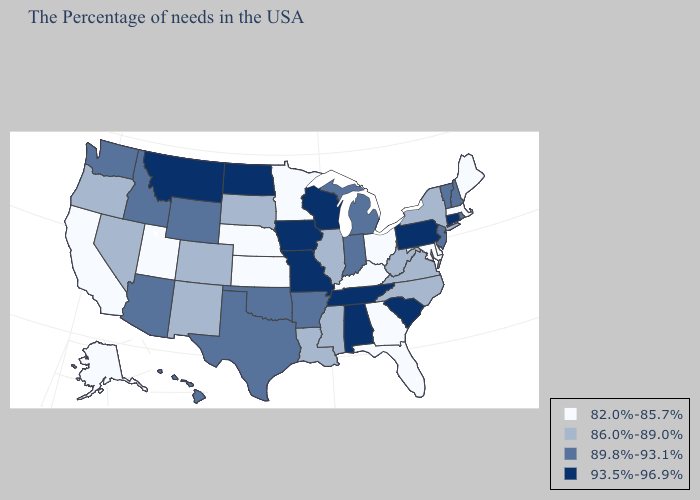What is the value of Kansas?
Quick response, please. 82.0%-85.7%. Which states hav the highest value in the Northeast?
Concise answer only. Connecticut, Pennsylvania. Name the states that have a value in the range 86.0%-89.0%?
Quick response, please. New York, Virginia, North Carolina, West Virginia, Illinois, Mississippi, Louisiana, South Dakota, Colorado, New Mexico, Nevada, Oregon. Does Louisiana have a higher value than Utah?
Give a very brief answer. Yes. What is the lowest value in states that border Florida?
Be succinct. 82.0%-85.7%. Does Colorado have the same value as Oklahoma?
Concise answer only. No. What is the lowest value in states that border Connecticut?
Short answer required. 82.0%-85.7%. Does Massachusetts have the lowest value in the Northeast?
Be succinct. Yes. What is the lowest value in states that border Alabama?
Short answer required. 82.0%-85.7%. Name the states that have a value in the range 89.8%-93.1%?
Concise answer only. Rhode Island, New Hampshire, Vermont, New Jersey, Michigan, Indiana, Arkansas, Oklahoma, Texas, Wyoming, Arizona, Idaho, Washington, Hawaii. Does Connecticut have the highest value in the USA?
Be succinct. Yes. What is the value of Maine?
Be succinct. 82.0%-85.7%. Which states have the highest value in the USA?
Quick response, please. Connecticut, Pennsylvania, South Carolina, Alabama, Tennessee, Wisconsin, Missouri, Iowa, North Dakota, Montana. Is the legend a continuous bar?
Keep it brief. No. What is the value of Oregon?
Quick response, please. 86.0%-89.0%. 